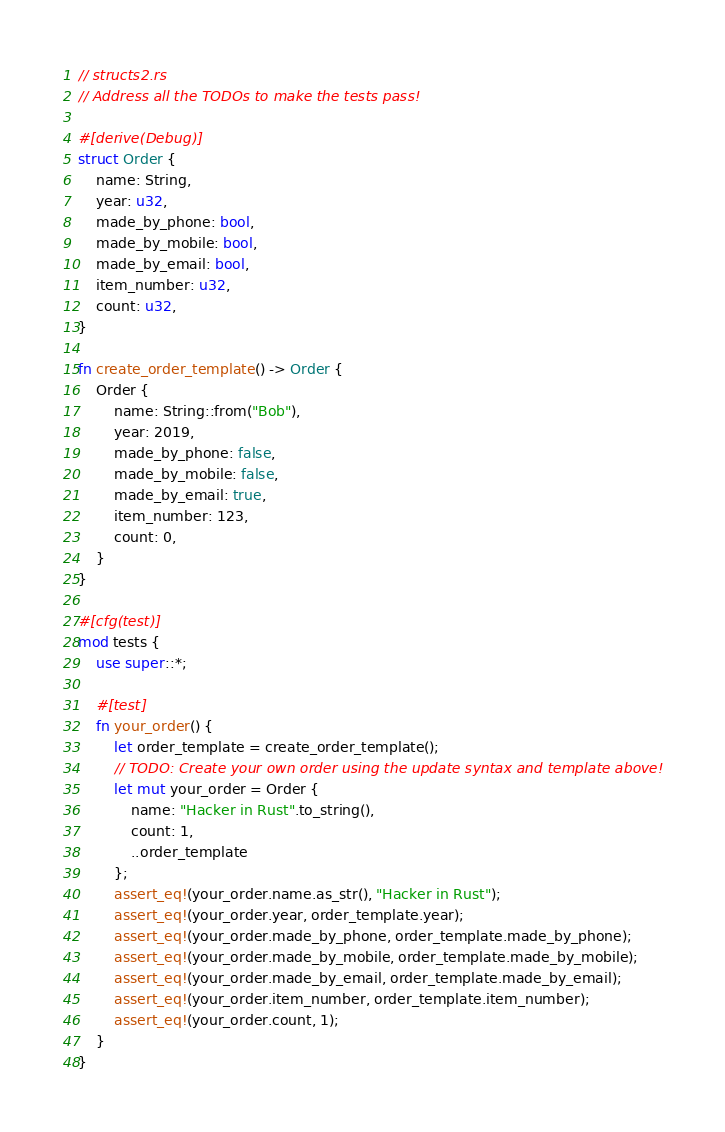<code> <loc_0><loc_0><loc_500><loc_500><_Rust_>// structs2.rs
// Address all the TODOs to make the tests pass!

#[derive(Debug)]
struct Order {
    name: String,
    year: u32,
    made_by_phone: bool,
    made_by_mobile: bool,
    made_by_email: bool,
    item_number: u32,
    count: u32,
}

fn create_order_template() -> Order {
    Order {
        name: String::from("Bob"),
        year: 2019,
        made_by_phone: false,
        made_by_mobile: false,
        made_by_email: true,
        item_number: 123,
        count: 0,
    }
}

#[cfg(test)]
mod tests {
    use super::*;

    #[test]
    fn your_order() {
        let order_template = create_order_template();
        // TODO: Create your own order using the update syntax and template above!
        let mut your_order = Order {
            name: "Hacker in Rust".to_string(),
            count: 1,
            ..order_template
        };
        assert_eq!(your_order.name.as_str(), "Hacker in Rust");
        assert_eq!(your_order.year, order_template.year);
        assert_eq!(your_order.made_by_phone, order_template.made_by_phone);
        assert_eq!(your_order.made_by_mobile, order_template.made_by_mobile);
        assert_eq!(your_order.made_by_email, order_template.made_by_email);
        assert_eq!(your_order.item_number, order_template.item_number);
        assert_eq!(your_order.count, 1);
    }
}
</code> 